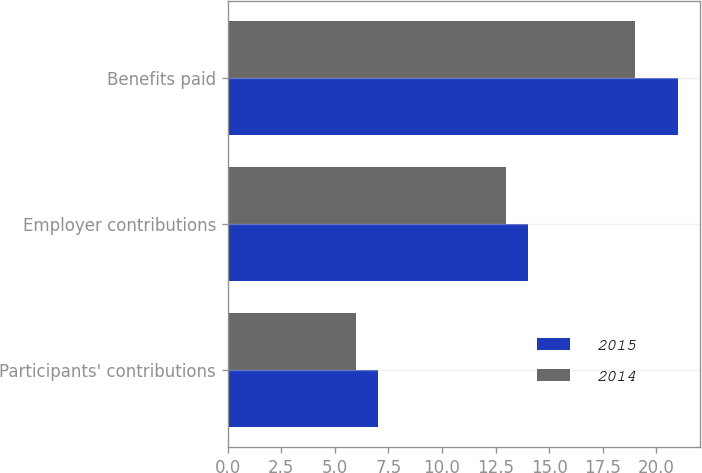Convert chart to OTSL. <chart><loc_0><loc_0><loc_500><loc_500><stacked_bar_chart><ecel><fcel>Participants' contributions<fcel>Employer contributions<fcel>Benefits paid<nl><fcel>2015<fcel>7<fcel>14<fcel>21<nl><fcel>2014<fcel>6<fcel>13<fcel>19<nl></chart> 